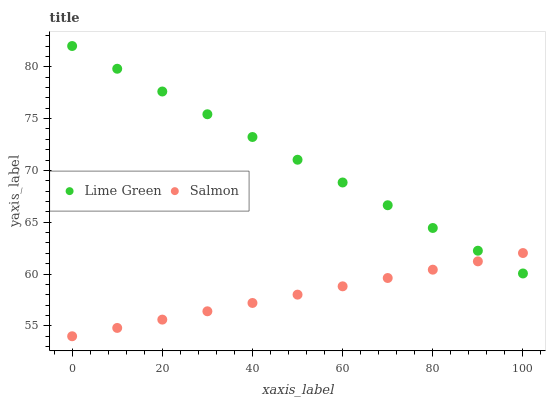Does Salmon have the minimum area under the curve?
Answer yes or no. Yes. Does Lime Green have the maximum area under the curve?
Answer yes or no. Yes. Does Lime Green have the minimum area under the curve?
Answer yes or no. No. Is Salmon the smoothest?
Answer yes or no. Yes. Is Lime Green the roughest?
Answer yes or no. Yes. Is Lime Green the smoothest?
Answer yes or no. No. Does Salmon have the lowest value?
Answer yes or no. Yes. Does Lime Green have the lowest value?
Answer yes or no. No. Does Lime Green have the highest value?
Answer yes or no. Yes. Does Lime Green intersect Salmon?
Answer yes or no. Yes. Is Lime Green less than Salmon?
Answer yes or no. No. Is Lime Green greater than Salmon?
Answer yes or no. No. 